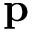<formula> <loc_0><loc_0><loc_500><loc_500>p</formula> 